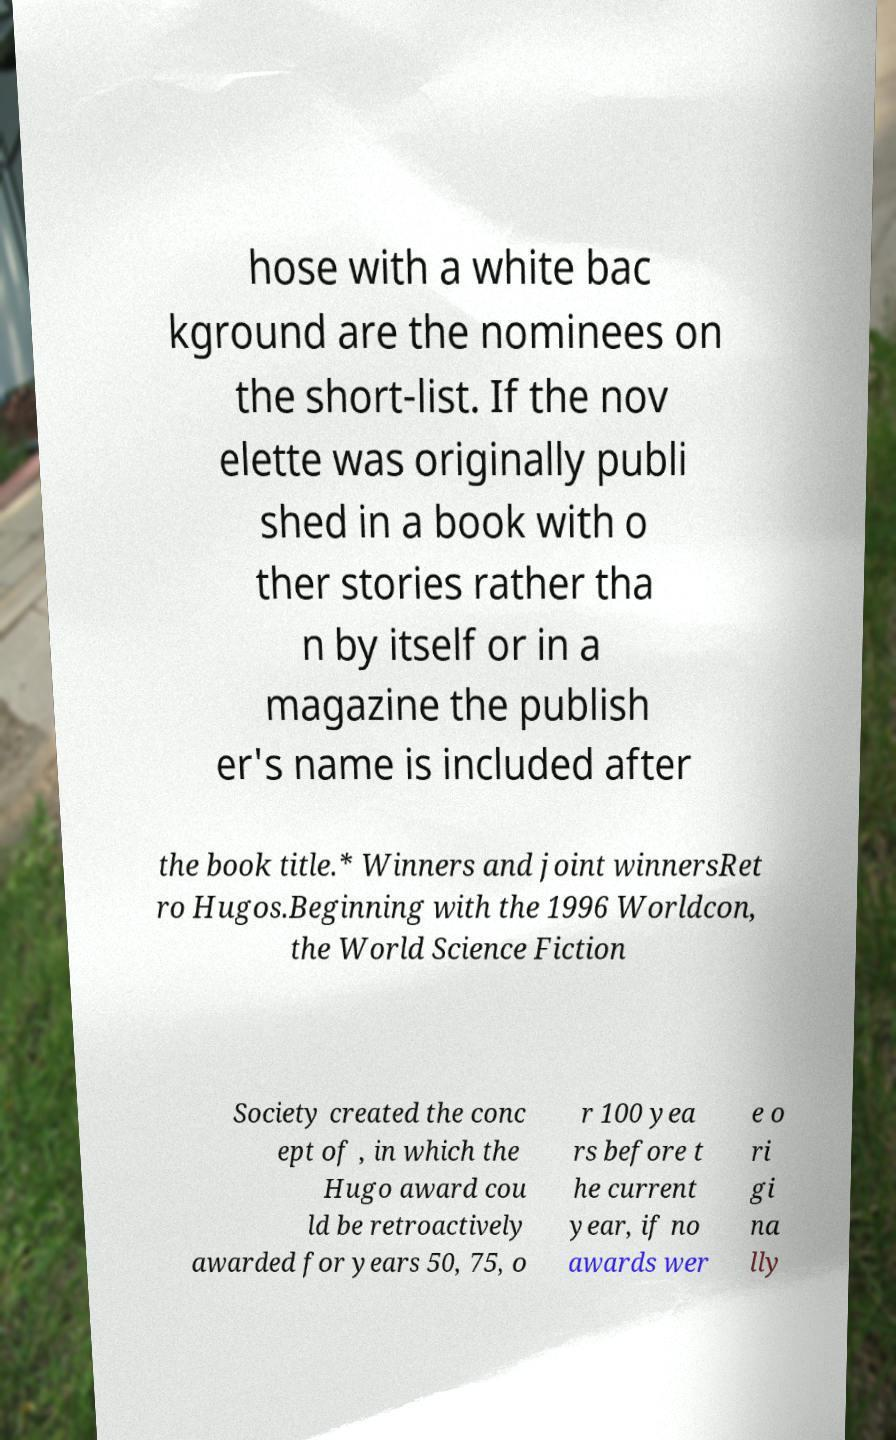I need the written content from this picture converted into text. Can you do that? hose with a white bac kground are the nominees on the short-list. If the nov elette was originally publi shed in a book with o ther stories rather tha n by itself or in a magazine the publish er's name is included after the book title.* Winners and joint winnersRet ro Hugos.Beginning with the 1996 Worldcon, the World Science Fiction Society created the conc ept of , in which the Hugo award cou ld be retroactively awarded for years 50, 75, o r 100 yea rs before t he current year, if no awards wer e o ri gi na lly 